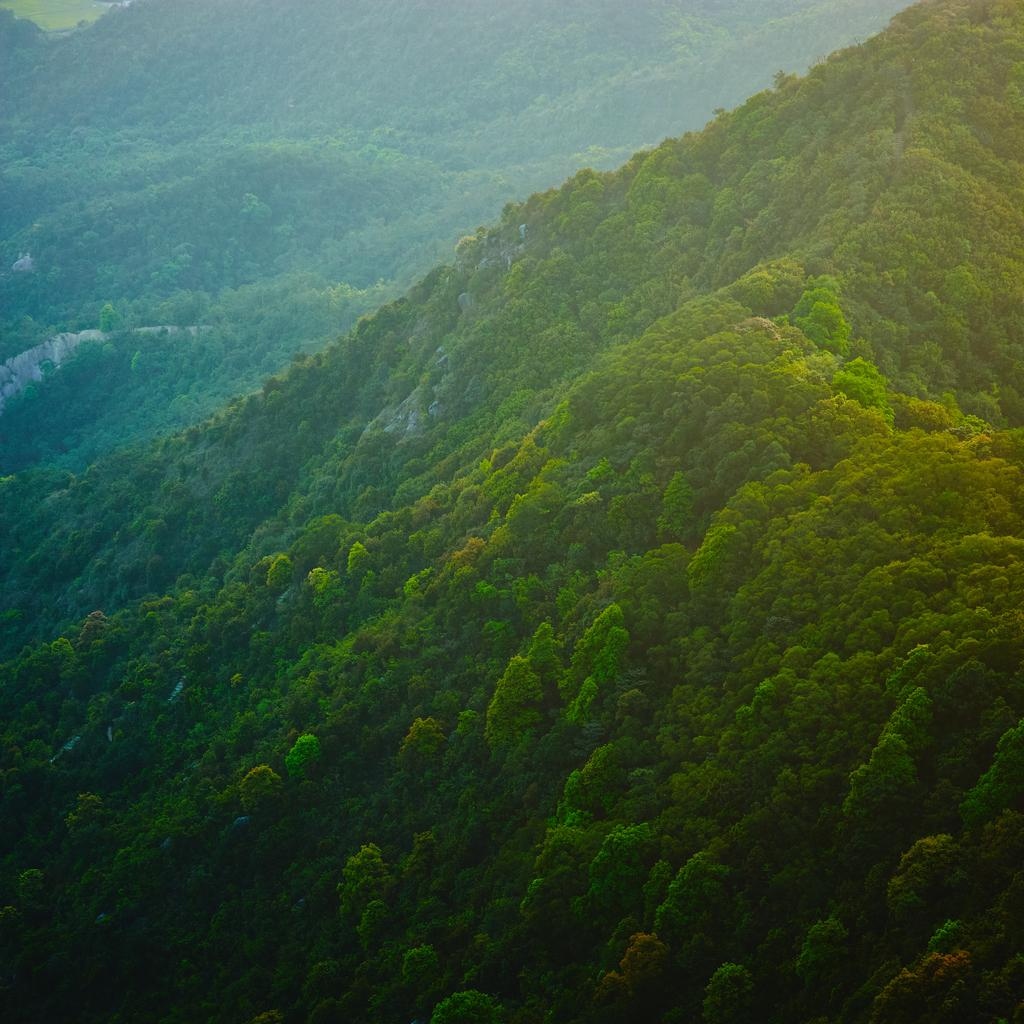What type of landscape is depicted in the image? The image features hills. What can be seen on the hills in the image? The hills are covered with trees. What type of arch can be seen in the image? There is no arch present in the image; it features hills covered with trees. 